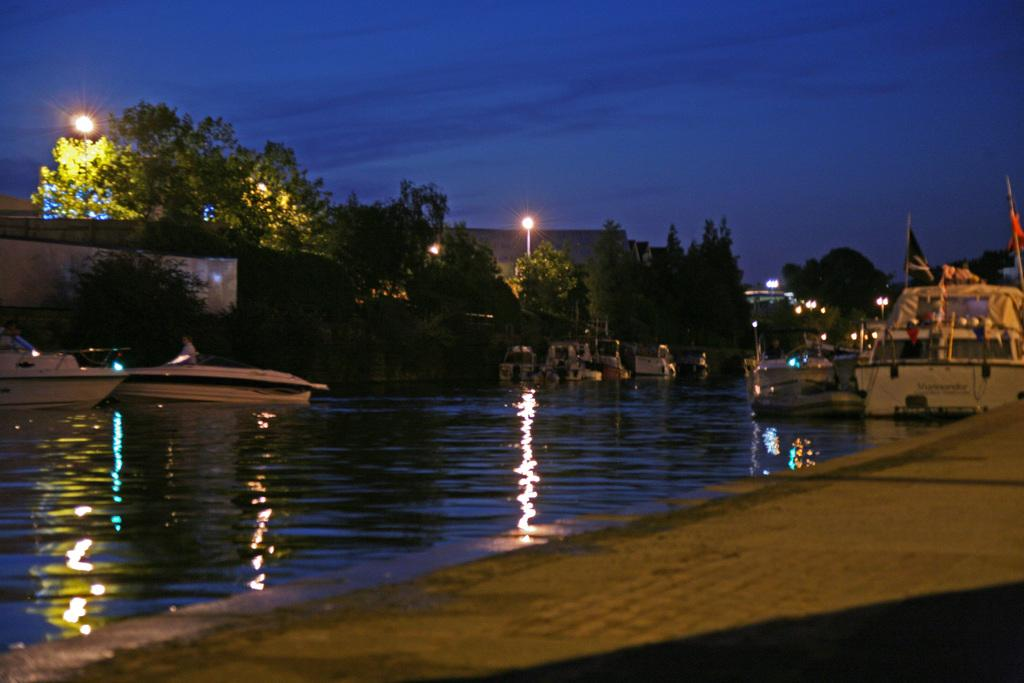What is on the water in the image? There are boats on the water in the image. What type of vegetation can be seen in the image? There are trees visible in the image. What objects in the image emit light? There are lights in the image. What type of decorative or symbolic objects are present in the image? There are flags in the image. What can be seen in the background of the image? The sky is visible in the background of the image. Where is the boy resting in the image? There is no boy present in the image, so it is not possible to answer the question about his rest. What type of bean is growing near the boats in the image? There are no beans visible in the image; it features boats on the water, trees, lights, flags, and a sky background. 